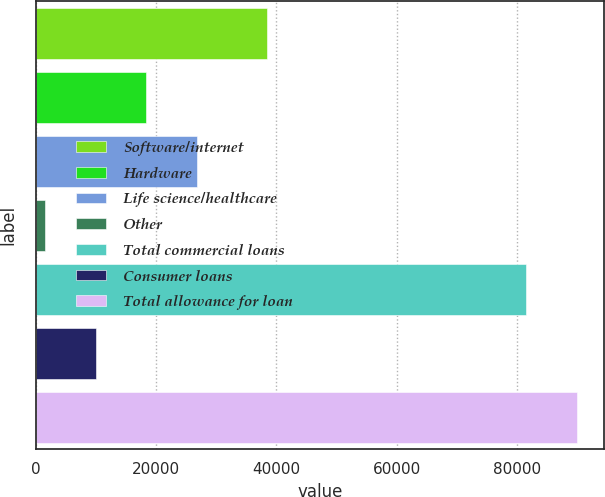Convert chart to OTSL. <chart><loc_0><loc_0><loc_500><loc_500><bar_chart><fcel>Software/internet<fcel>Hardware<fcel>Life science/healthcare<fcel>Other<fcel>Total commercial loans<fcel>Consumer loans<fcel>Total allowance for loan<nl><fcel>38462<fcel>18355<fcel>26803<fcel>1459<fcel>81553<fcel>9907<fcel>90001<nl></chart> 